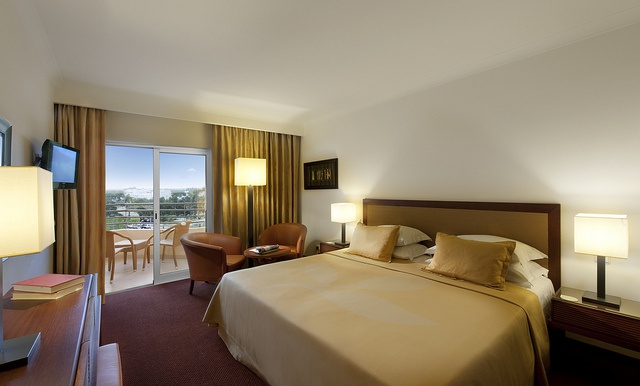Describe the objects in this image and their specific colors. I can see bed in gray, tan, olive, and maroon tones, chair in gray, black, maroon, and brown tones, chair in gray, maroon, black, and brown tones, tv in gray, black, darkgray, and lightblue tones, and book in gray, salmon, tan, and maroon tones in this image. 